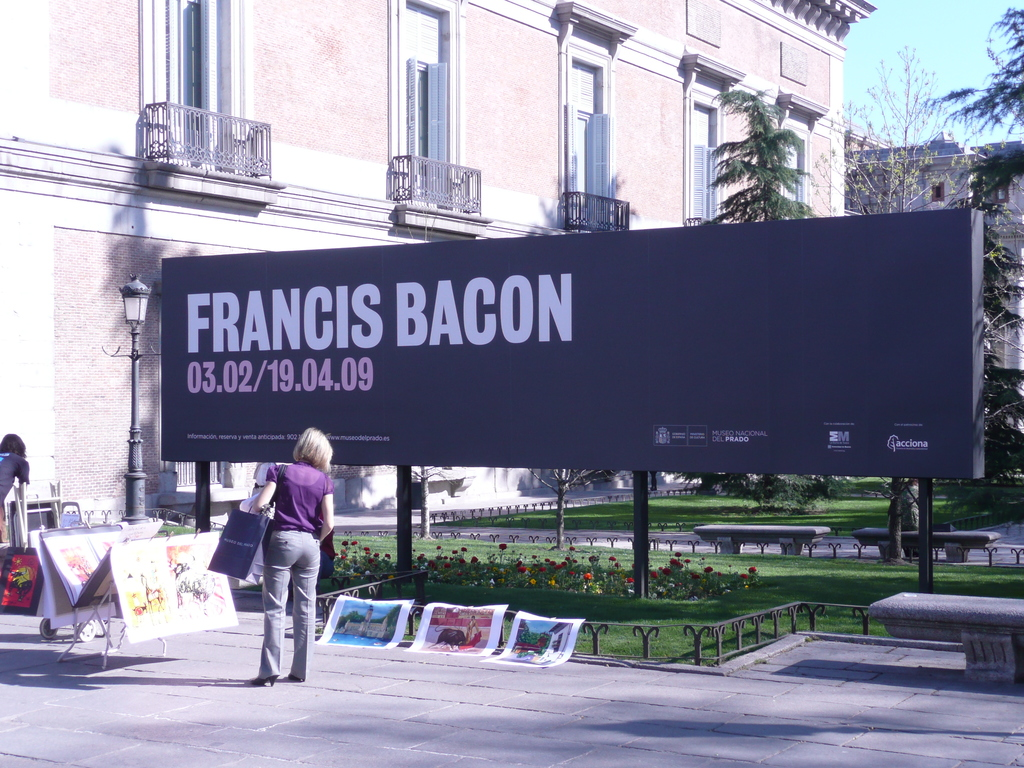Provide a one-sentence caption for the provided image. A woman examines artworks for sale in front of a large promotional billboard for a Francis Bacon exhibition at the Museo Nacional del Prado, highlighting the intersection of public art displays and personal art appreciation. 